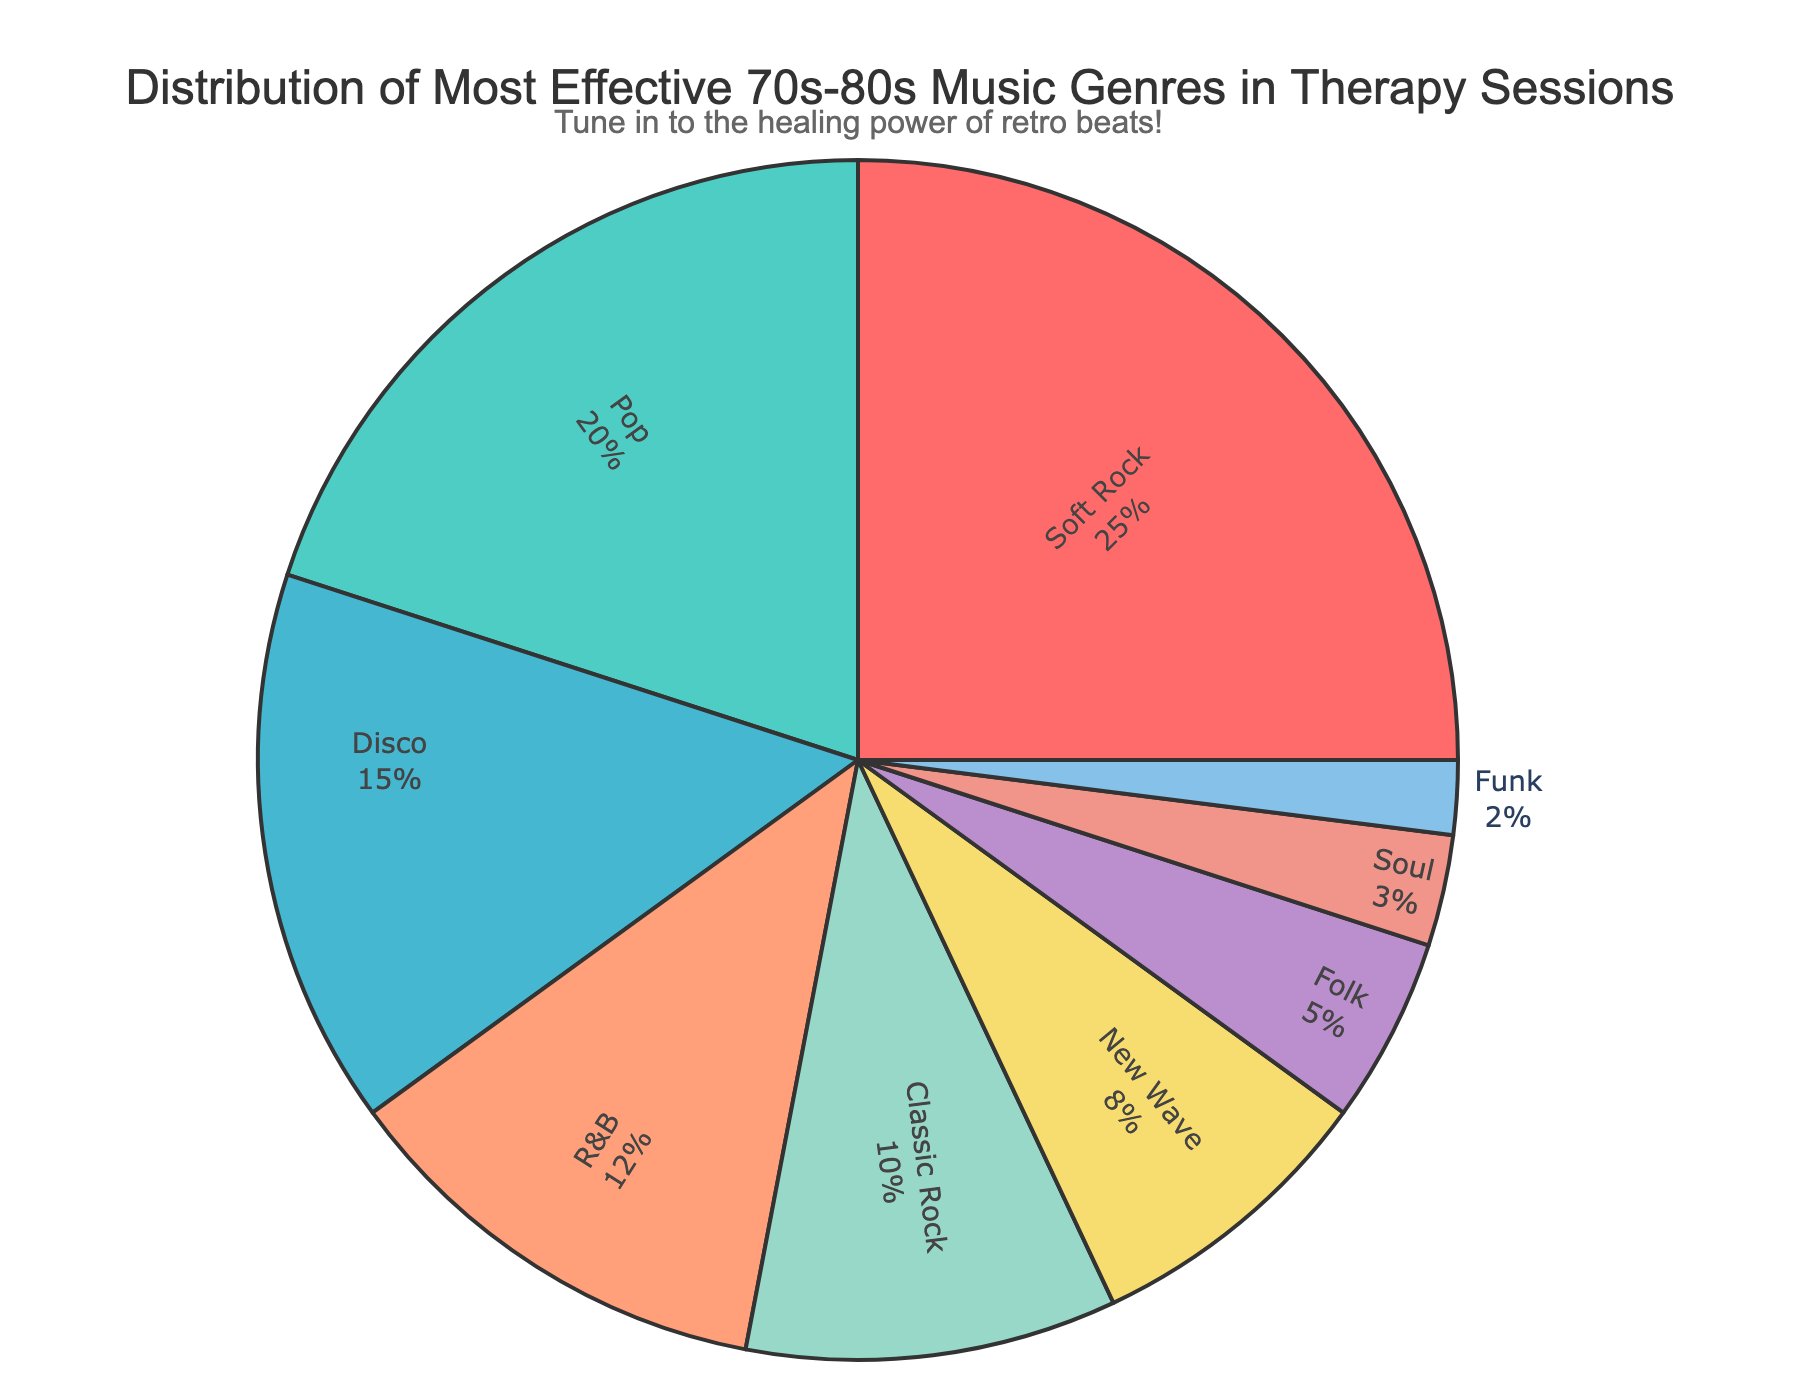Which genre holds the largest percentage in the distribution? The largest portion in the pie chart is labeled with "25%", corresponding to the Soft Rock genre.
Answer: Soft Rock What is the combined percentage for Pop and Disco genres? Pop accounts for 20% and Disco accounts for 15%. Adding these together: 20% + 15% = 35%.
Answer: 35% Between R&B and New Wave, which genre has a higher percentage and by how much? R&B has 12%, and New Wave has 8%. The difference is 12% - 8% = 4%.
Answer: R&B by 4% What genres make up 30% of the distribution? Classic Rock (10%) and New Wave (8%) together make 18%, needing 12% more. Adding R&B (12%), they together sum up to 10% + 8% + 12% = 30%.
Answer: Classic Rock, New Wave, and R&B What is the total percentage for genres making up less than 10% each? Classic Rock (10%) is excluded. Adding New Wave (8%), Folk (5%), Soul (3%), and Funk (2%): 8% + 5% + 3% + 2% = 18%.
Answer: 18% What percentage more is attributed to Soft Rock compared to Pop? Soft Rock has 25%, and Pop has 20%. The difference is 25% - 20% = 5%.
Answer: 5% How many genres together sum up to at least 50% of the distribution? Adding the highest percentages until reaching at least 50%: Soft Rock (25%) + Pop (20%) = 45%, then include Disco (15%): 25% + 20% + 15% = 60%. Three genres are needed.
Answer: 3 Which genre segment is represented with the light green color in the chart? The segment colored light green corresponds to Disco with a percentage of 15%.
Answer: Disco What is the smallest genre percentage, and what is it? The smallest segment in the pie chart represents Funk, which accounts for 2%.
Answer: Funk with 2% How much space does Folk take in relation to R&B in the distribution? Folk is 5%, and R&B is 12%. The ratio of Folk to R&B is 5% / 12% ≈ 0.417.
Answer: Approximately 0.417 